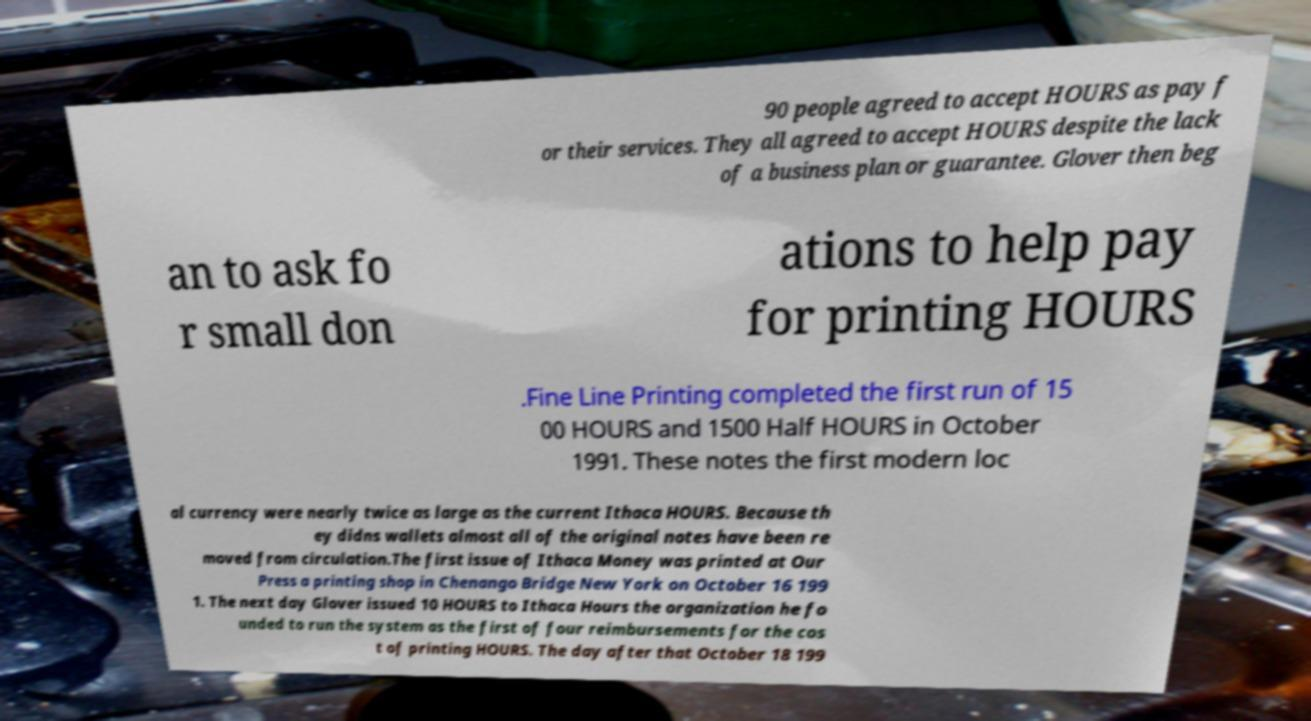What messages or text are displayed in this image? I need them in a readable, typed format. 90 people agreed to accept HOURS as pay f or their services. They all agreed to accept HOURS despite the lack of a business plan or guarantee. Glover then beg an to ask fo r small don ations to help pay for printing HOURS .Fine Line Printing completed the first run of 15 00 HOURS and 1500 Half HOURS in October 1991. These notes the first modern loc al currency were nearly twice as large as the current Ithaca HOURS. Because th ey didns wallets almost all of the original notes have been re moved from circulation.The first issue of Ithaca Money was printed at Our Press a printing shop in Chenango Bridge New York on October 16 199 1. The next day Glover issued 10 HOURS to Ithaca Hours the organization he fo unded to run the system as the first of four reimbursements for the cos t of printing HOURS. The day after that October 18 199 